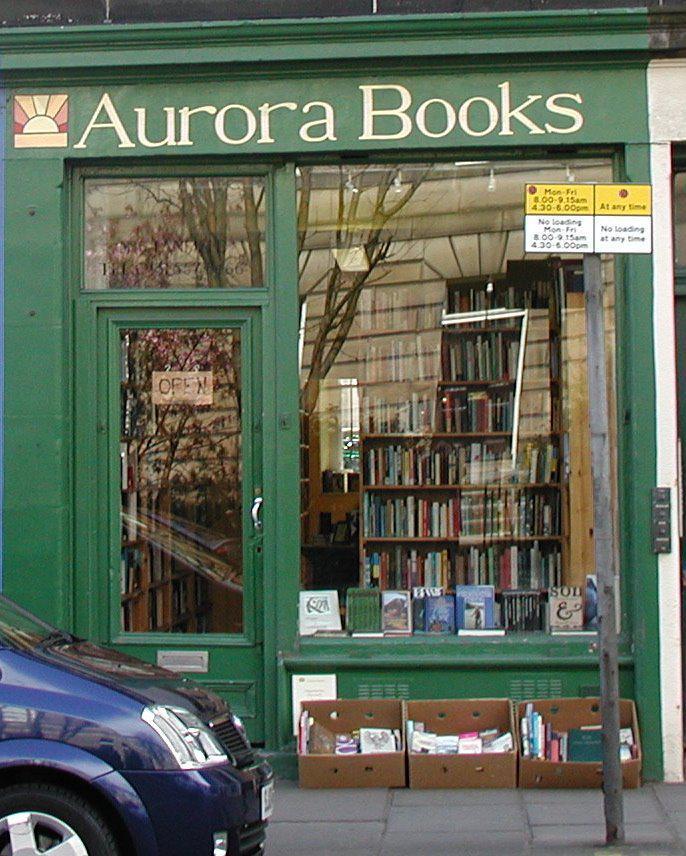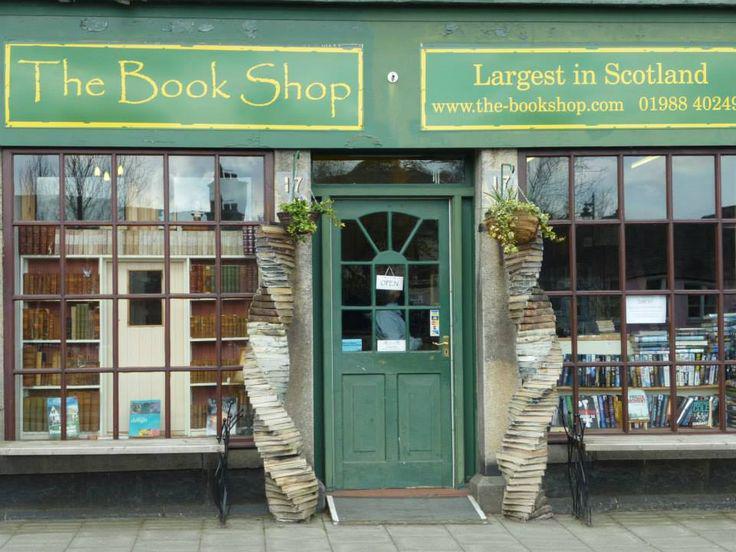The first image is the image on the left, the second image is the image on the right. Assess this claim about the two images: "The book shops pictured in the images on the left and right have the same color paint on their exterior, and at least one shop has windows divided into small panes.". Correct or not? Answer yes or no. Yes. 